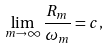<formula> <loc_0><loc_0><loc_500><loc_500>\lim _ { m \rightarrow \infty } \frac { R _ { m } } { \omega _ { m } } = c ,</formula> 